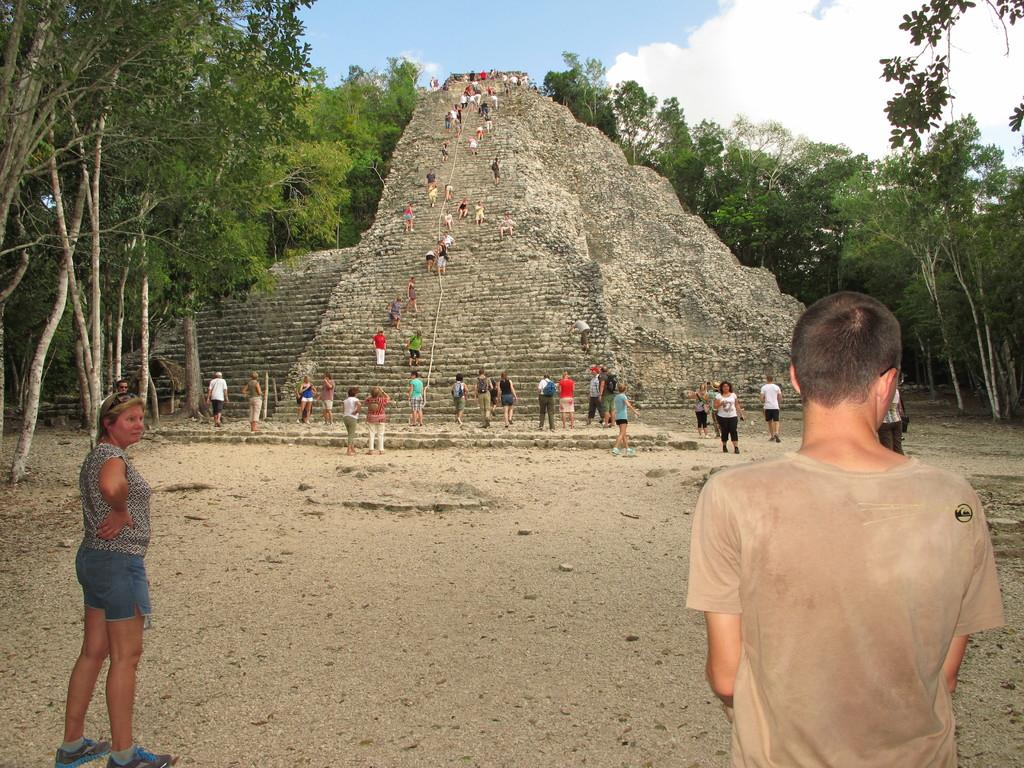Who or what can be seen in the image? There are people in the image. What is the main structure in the middle of the image? There is a pyramid in the middle of the image. What are some of the people doing in the image? Some people are walking. What type of natural environment is visible in the image? There are trees visible in the image. What is visible in the background of the image? The sky is visible in the image, and clouds are present in the sky. How many lizards can be seen playing a game of question at the club in the image? There are no lizards, games of question, or clubs present in the image. 